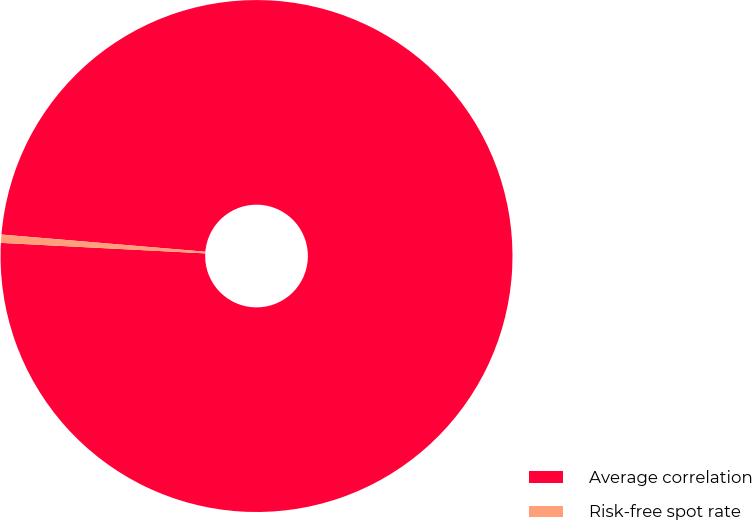Convert chart to OTSL. <chart><loc_0><loc_0><loc_500><loc_500><pie_chart><fcel>Average correlation<fcel>Risk-free spot rate<nl><fcel>99.48%<fcel>0.52%<nl></chart> 